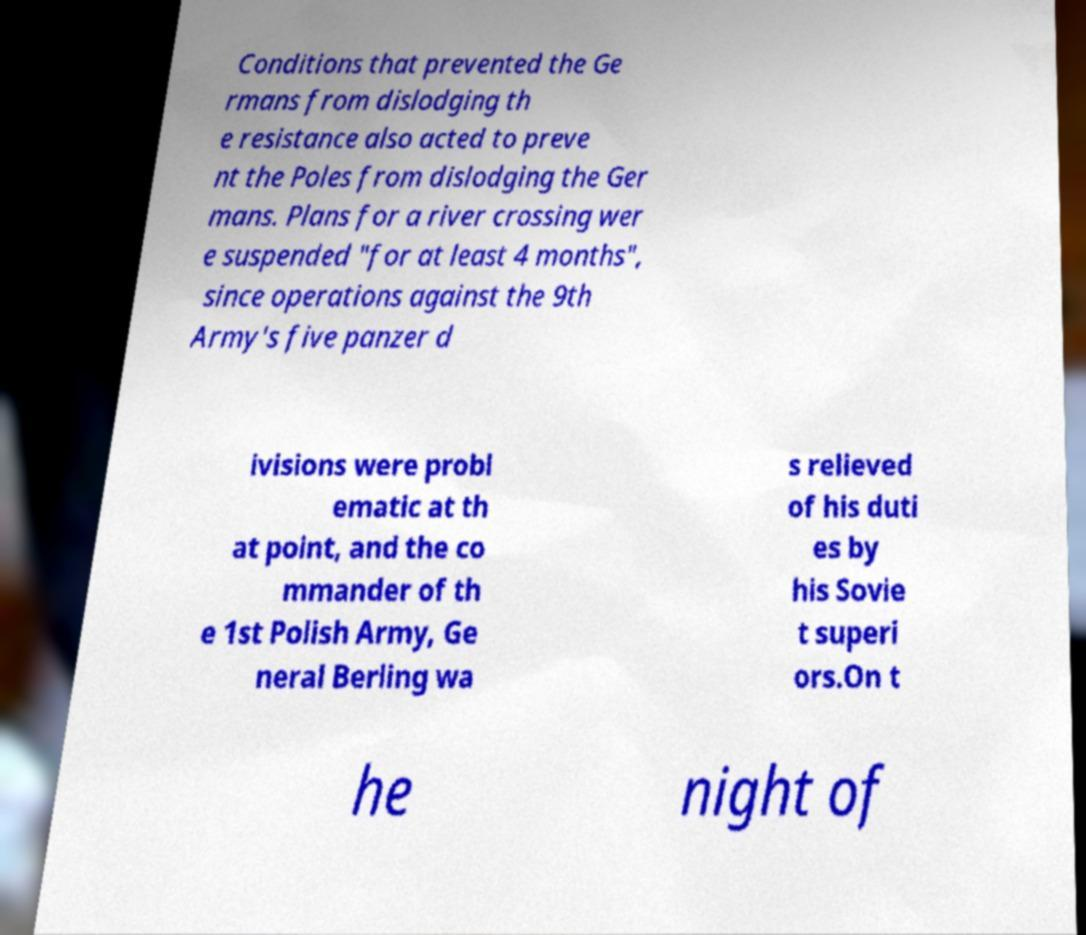There's text embedded in this image that I need extracted. Can you transcribe it verbatim? Conditions that prevented the Ge rmans from dislodging th e resistance also acted to preve nt the Poles from dislodging the Ger mans. Plans for a river crossing wer e suspended "for at least 4 months", since operations against the 9th Army's five panzer d ivisions were probl ematic at th at point, and the co mmander of th e 1st Polish Army, Ge neral Berling wa s relieved of his duti es by his Sovie t superi ors.On t he night of 